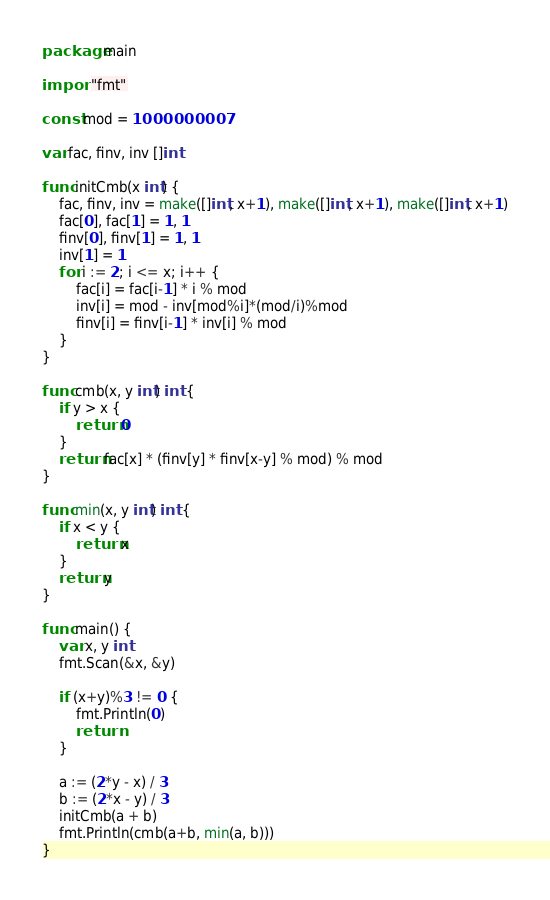Convert code to text. <code><loc_0><loc_0><loc_500><loc_500><_Go_>package main

import "fmt"

const mod = 1000000007

var fac, finv, inv []int

func initCmb(x int) {
	fac, finv, inv = make([]int, x+1), make([]int, x+1), make([]int, x+1)
	fac[0], fac[1] = 1, 1
	finv[0], finv[1] = 1, 1
	inv[1] = 1
	for i := 2; i <= x; i++ {
		fac[i] = fac[i-1] * i % mod
		inv[i] = mod - inv[mod%i]*(mod/i)%mod
		finv[i] = finv[i-1] * inv[i] % mod
	}
}

func cmb(x, y int) int {
	if y > x {
		return 0
	}
	return fac[x] * (finv[y] * finv[x-y] % mod) % mod
}

func min(x, y int) int {
	if x < y {
		return x
	}
	return y
}

func main() {
	var x, y int
	fmt.Scan(&x, &y)

	if (x+y)%3 != 0 {
		fmt.Println(0)
		return
	}

	a := (2*y - x) / 3
	b := (2*x - y) / 3
	initCmb(a + b)
	fmt.Println(cmb(a+b, min(a, b)))
}
</code> 